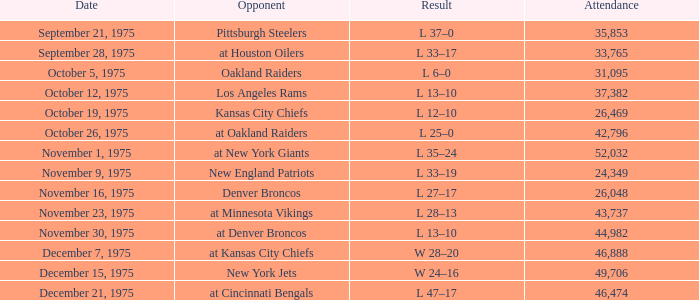What is the highest Week when the opponent was the los angeles rams, with more than 37,382 in Attendance? None. 